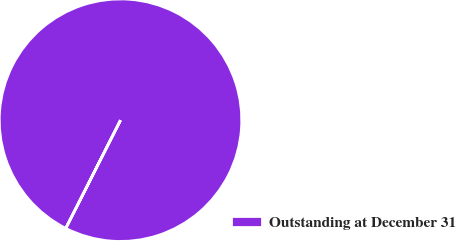Convert chart to OTSL. <chart><loc_0><loc_0><loc_500><loc_500><pie_chart><fcel>Outstanding at December 31<nl><fcel>100.0%<nl></chart> 